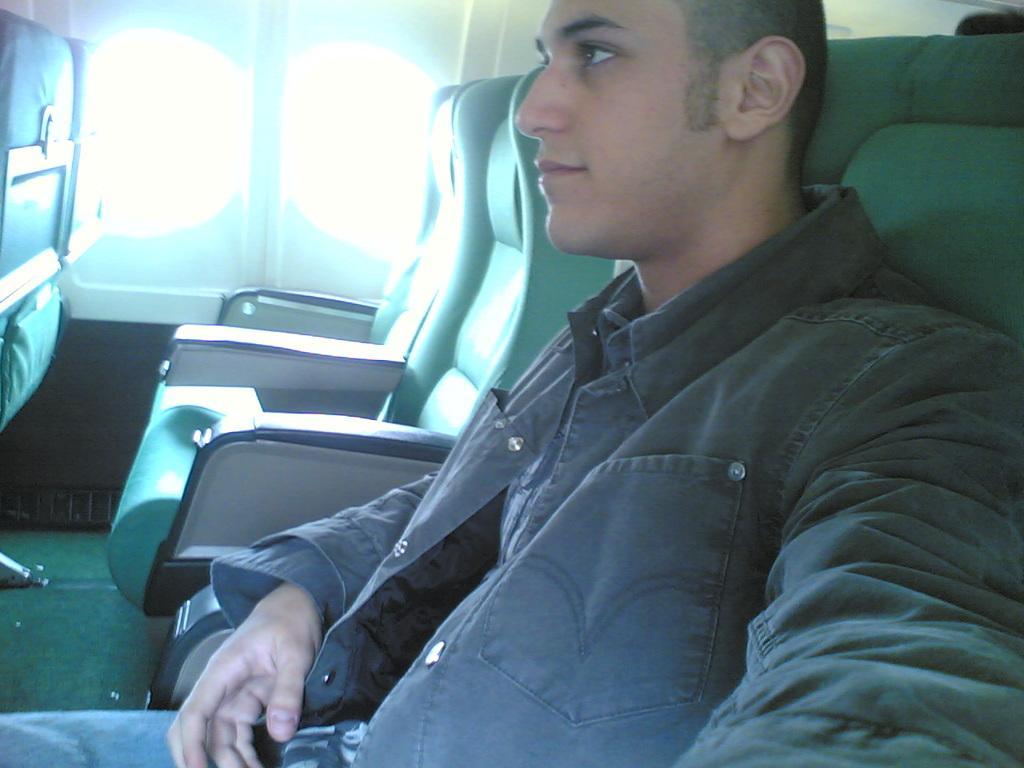How would you summarize this image in a sentence or two? In this image there is an inside view of an airplane, there is a person sitting on the seat, there is a seat truncated towards the right of the image, there is a seat truncated towards the left of the image, there are windows. 